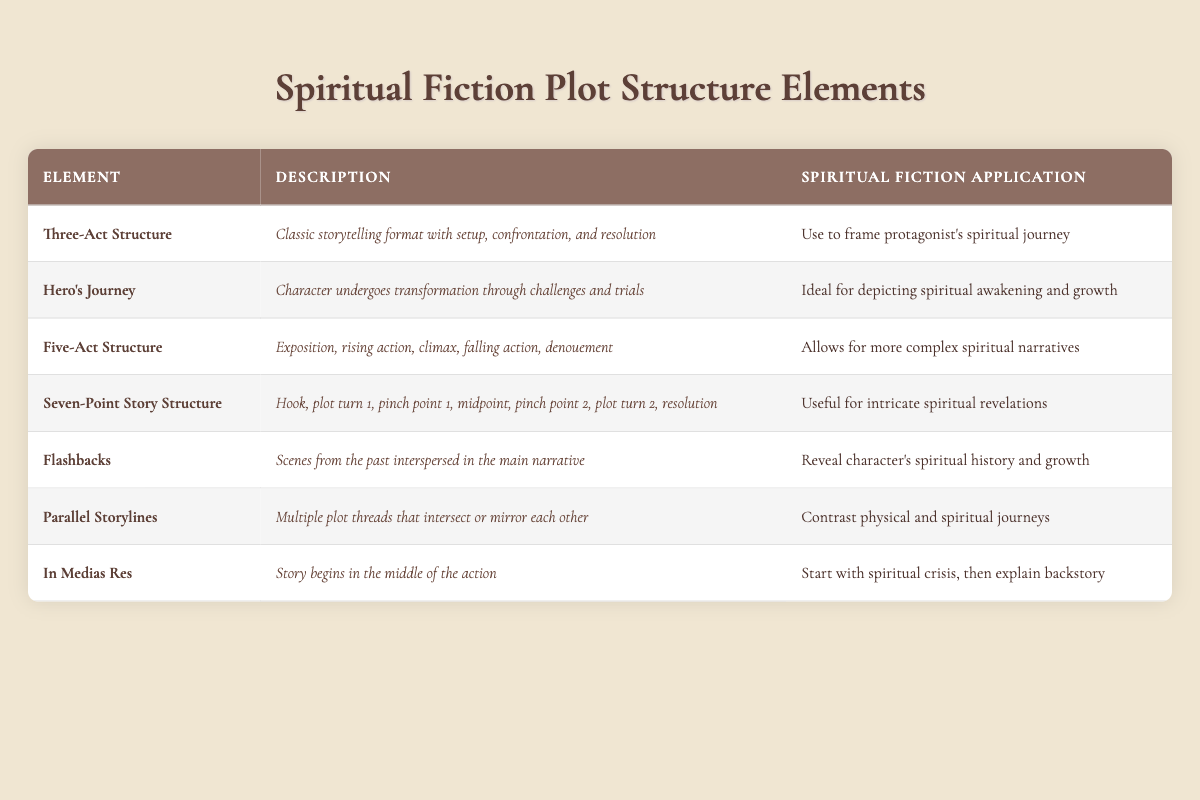What is the spiritual fiction application of the Three-Act Structure? The table states that the Three-Act Structure is used to frame the protagonist's spiritual journey.
Answer: Frame protagonist's spiritual journey Which plot structure element describes a character's transformation through challenges? The Hero's Journey describes a character's transformation through challenges and trials, according to the table.
Answer: Hero's Journey Is the Five-Act Structure more complex than the Three-Act Structure? Yes, the Five-Act Structure allows for more complex spiritual narratives compared to the classic three-act format.
Answer: Yes What is the purpose of using Flashbacks in spiritual fiction? The table indicates that Flashbacks reveal a character's spiritual history and growth, illustrating their past experiences relevant to their journey.
Answer: Reveal spiritual history and growth In how many plot structure elements is the concept of spiritual growth mentioned? Spiritual growth is mentioned explicitly in the Hero's Journey and Flashbacks. Thus, there are two elements that discuss it directly.
Answer: 2 Does the Seven-Point Story Structure offer a specific application to spiritual fiction? Yes, the Seven-Point Story Structure is useful for intricate spiritual revelations, as noted in the table.
Answer: Yes Which plot structure element begins the narrative in the middle of the action? In the table, In Medias Res is identified as the plot structure element that starts in the middle of the action.
Answer: In Medias Res How does Parallel Storylines contribute to spiritual fiction narratives? According to the table, Parallel Storylines contrast physical and spiritual journeys, providing depth to character development.
Answer: Contrast physical and spiritual journeys Which plot structure elements are mentioned to be associated with spiritual awakening or growth? The Hero's Journey and Flashbacks are both associated with spiritual awakening and growth, as outlined in the table.
Answer: Hero's Journey and Flashbacks If you were to combine the Hero's Journey with Flashbacks, what thematic depth could this create? Combining these elements would depict a character's transformation through challenges while also revealing their spiritual history, potentially enhancing the narrative's depth and emotional resonance.
Answer: Enhanced thematic depth through transformation and history 